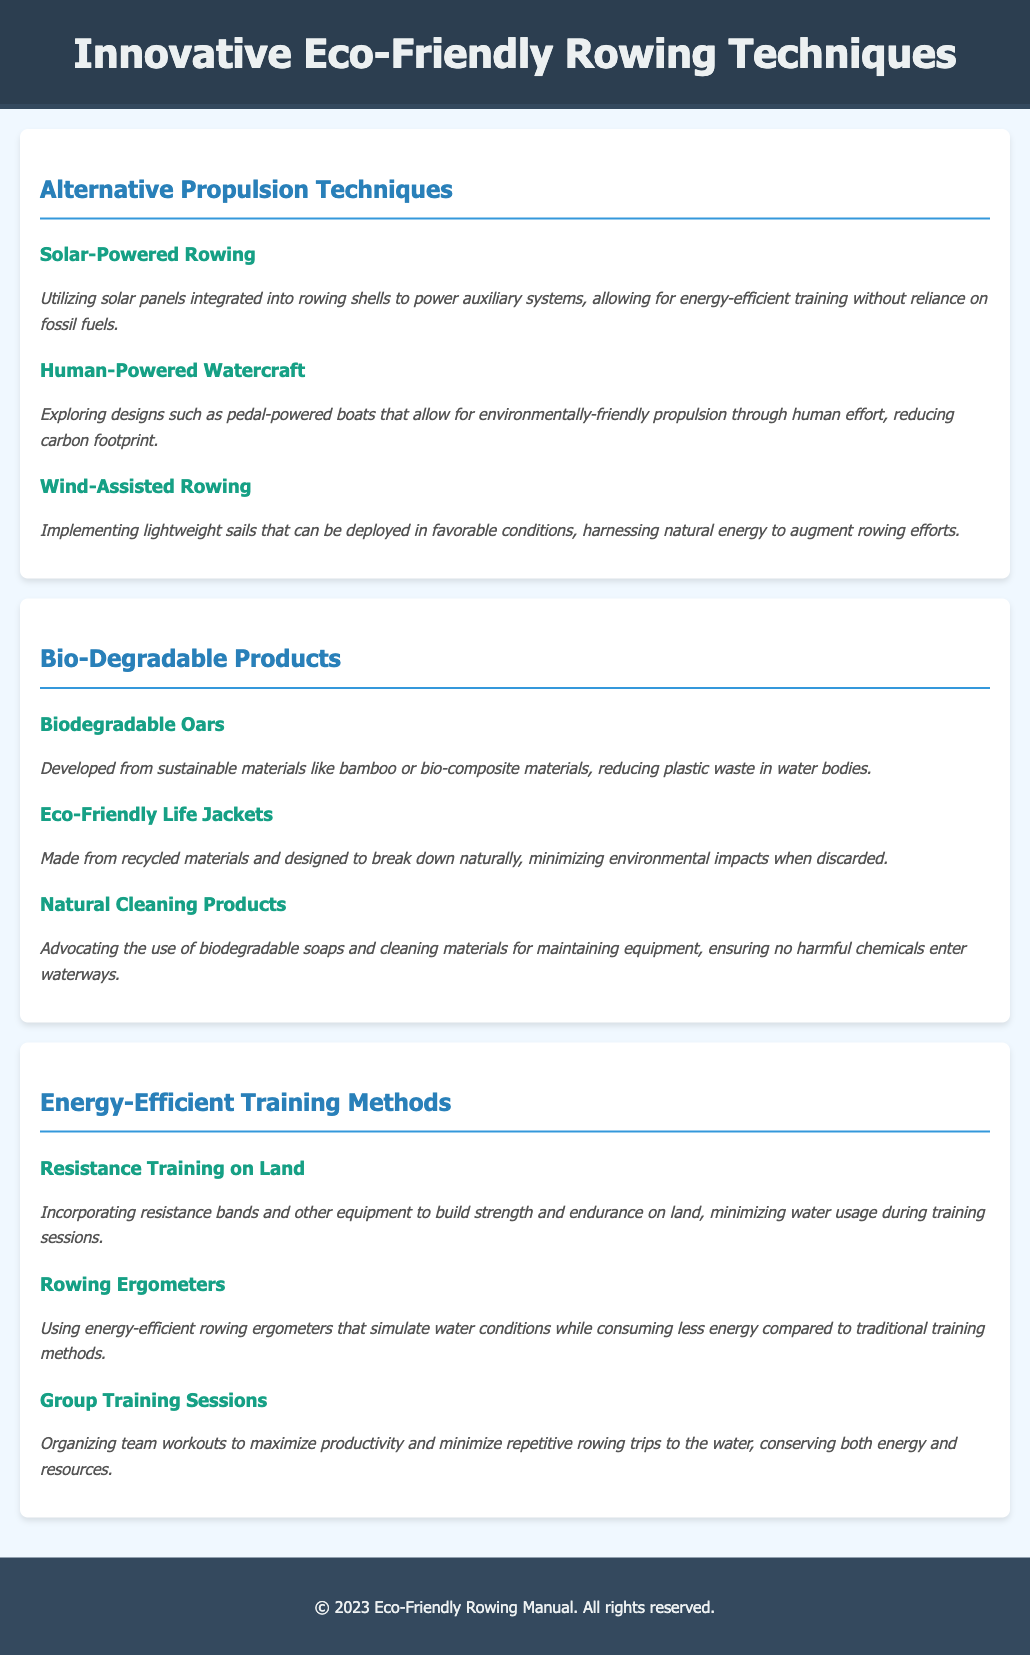What is one alternative propulsion technique mentioned? The document lists alternative propulsion techniques, including solar-powered rowing, human-powered watercraft, and wind-assisted rowing.
Answer: Solar-Powered Rowing What material is suggested for biodegradable oars? The document states that biodegradable oars are developed from sustainable materials like bamboo or bio-composite materials.
Answer: Bamboo What type of life jackets are mentioned? The section on biodegradable products includes eco-friendly life jackets that are made from recycled materials.
Answer: Eco-Friendly Life Jackets How many energy-efficient training methods are provided? The section lists three energy-efficient training methods: resistance training on land, rowing ergometers, and group training sessions.
Answer: Three What is one benefit of using rowing ergometers? The description of rowing ergometers highlights that they simulate water conditions while consuming less energy.
Answer: Consuming less energy What is a key advantage of group training sessions? The document states that group training sessions can maximize productivity and minimize repetitive rowing trips, conserving resources.
Answer: Conserving resources What does the document advocate for cleaning equipment? The manual discusses using biodegradable soaps and cleaning materials to ensure no harmful chemicals enter waterways.
Answer: Natural Cleaning Products What is a unique aspect of wind-assisted rowing? The technique involves implementing lightweight sails that can be deployed in favorable conditions to harness natural energy.
Answer: Harnessing natural energy 